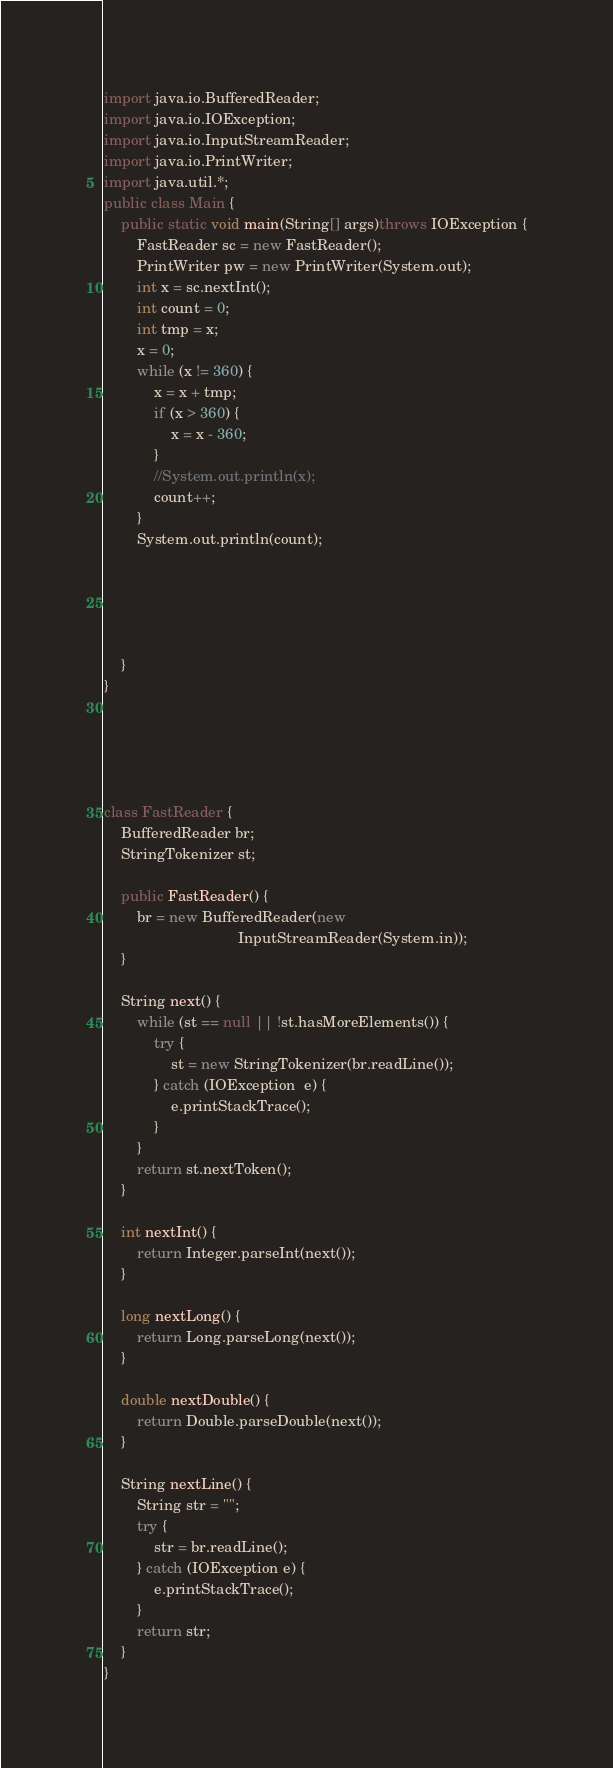<code> <loc_0><loc_0><loc_500><loc_500><_Java_>import java.io.BufferedReader;
import java.io.IOException;
import java.io.InputStreamReader;
import java.io.PrintWriter;
import java.util.*;
public class Main {
	public static void main(String[] args)throws IOException {
		FastReader sc = new FastReader();
		PrintWriter pw = new PrintWriter(System.out);
		int x = sc.nextInt();
		int count = 0;
		int tmp = x;
		x = 0;
		while (x != 360) {
			x = x + tmp;
			if (x > 360) {
				x = x - 360;
			}
			//System.out.println(x);
			count++;
		}
		System.out.println(count);





	}
}





class FastReader {
	BufferedReader br;
	StringTokenizer st;

	public FastReader() {
		br = new BufferedReader(new
		                        InputStreamReader(System.in));
	}

	String next() {
		while (st == null || !st.hasMoreElements()) {
			try {
				st = new StringTokenizer(br.readLine());
			} catch (IOException  e) {
				e.printStackTrace();
			}
		}
		return st.nextToken();
	}

	int nextInt() {
		return Integer.parseInt(next());
	}

	long nextLong() {
		return Long.parseLong(next());
	}

	double nextDouble() {
		return Double.parseDouble(next());
	}

	String nextLine() {
		String str = "";
		try {
			str = br.readLine();
		} catch (IOException e) {
			e.printStackTrace();
		}
		return str;
	}
}</code> 